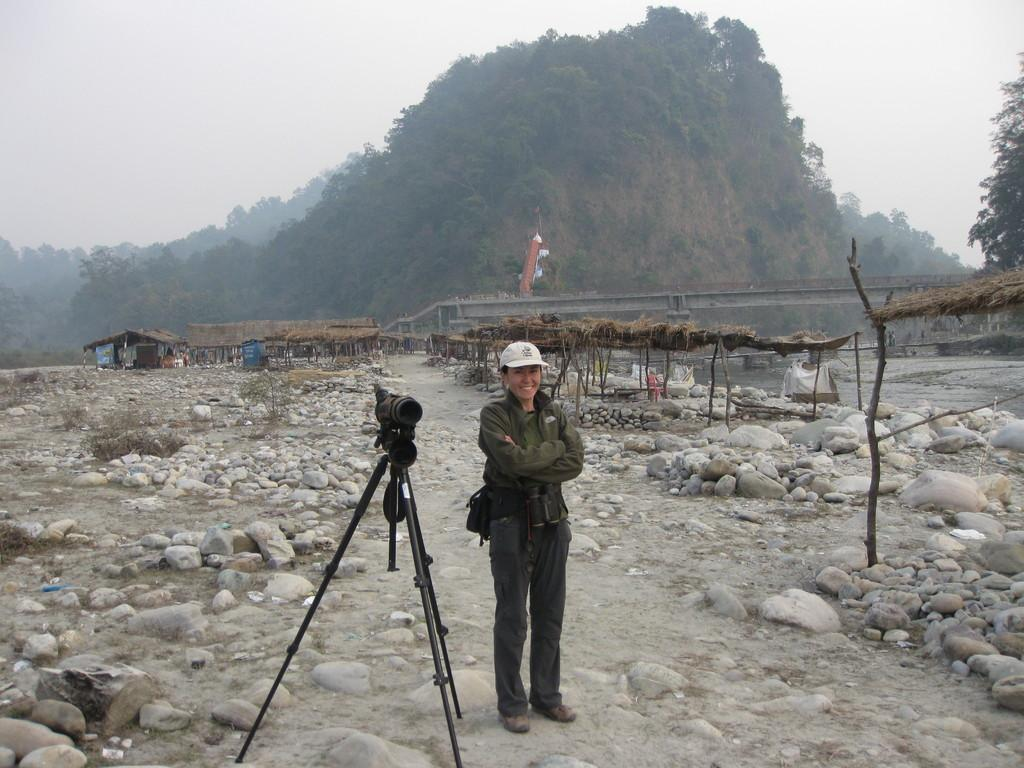What is the main subject in the center of the image? There is a person standing in the center of the image. What object is used for capturing images in the image? There is a camera placed on a stand in the image. What type of natural elements can be seen in the image? Stones, trees, and the sky are visible in the image. What type of structures are visible in the background of the image? There are sheds in the background of the image. How does the number of insects in the image compare to the number of stones? There is no mention of insects in the image, so it is impossible to make a comparison. 